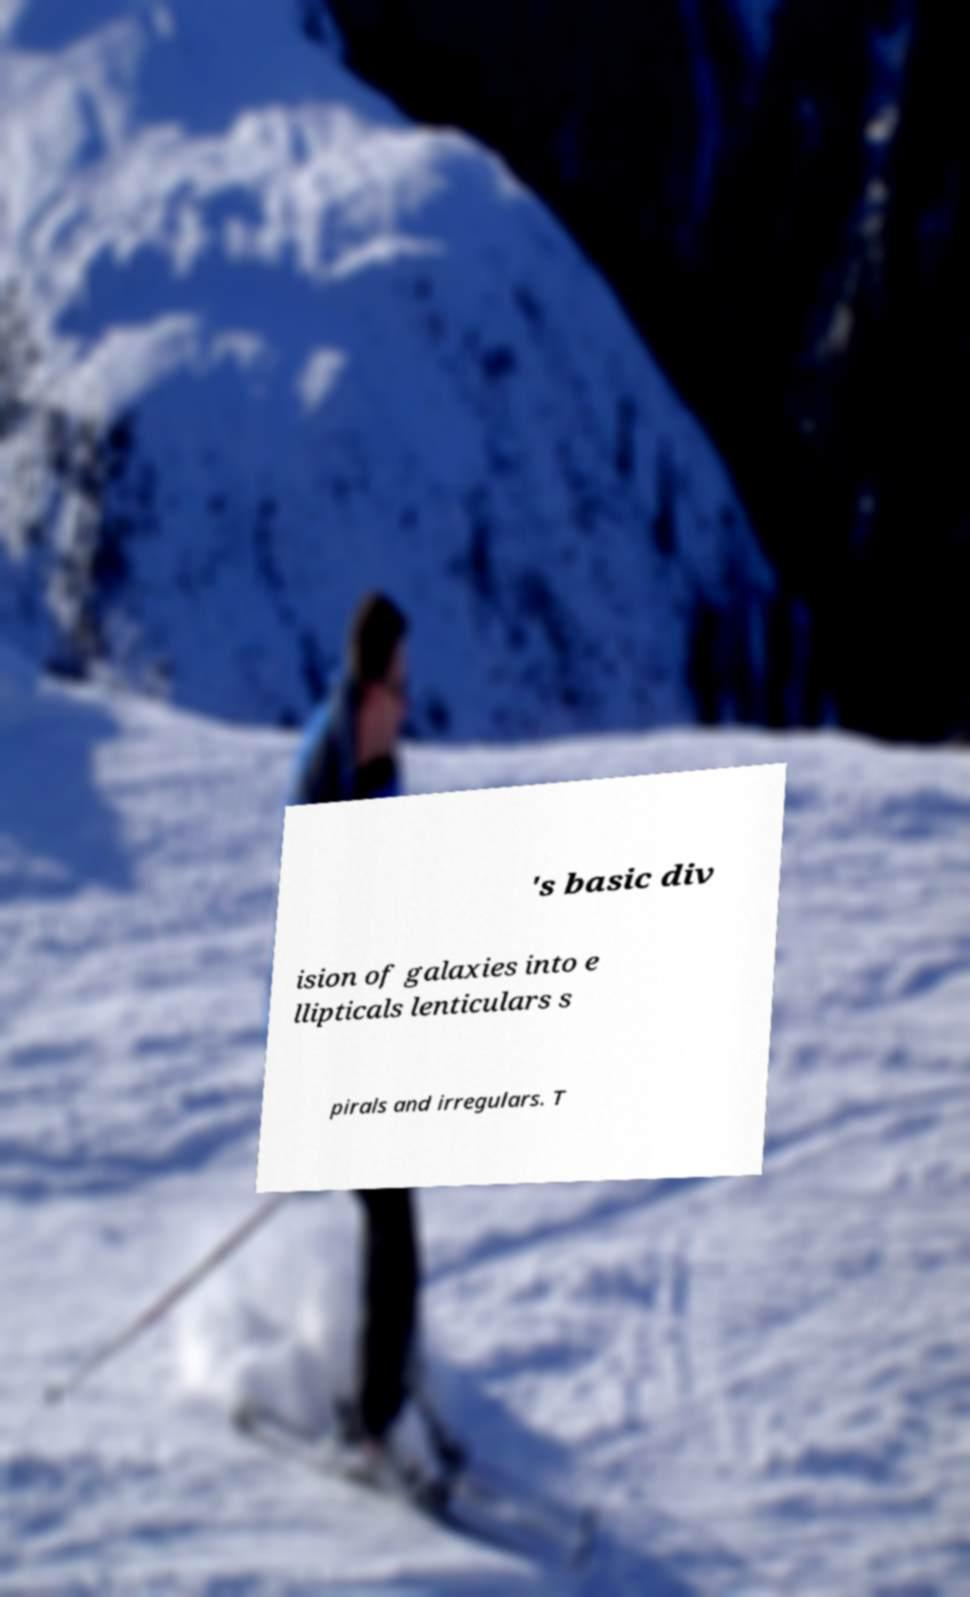Could you extract and type out the text from this image? 's basic div ision of galaxies into e llipticals lenticulars s pirals and irregulars. T 